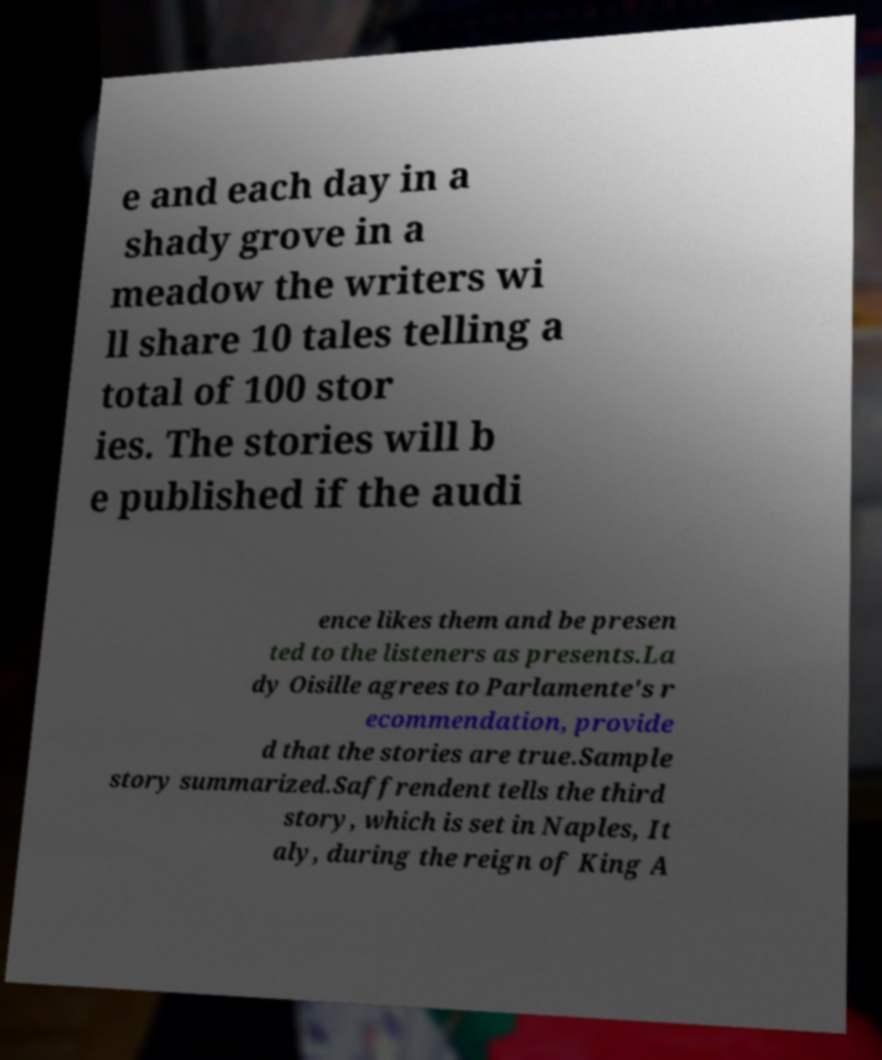Please identify and transcribe the text found in this image. e and each day in a shady grove in a meadow the writers wi ll share 10 tales telling a total of 100 stor ies. The stories will b e published if the audi ence likes them and be presen ted to the listeners as presents.La dy Oisille agrees to Parlamente's r ecommendation, provide d that the stories are true.Sample story summarized.Saffrendent tells the third story, which is set in Naples, It aly, during the reign of King A 